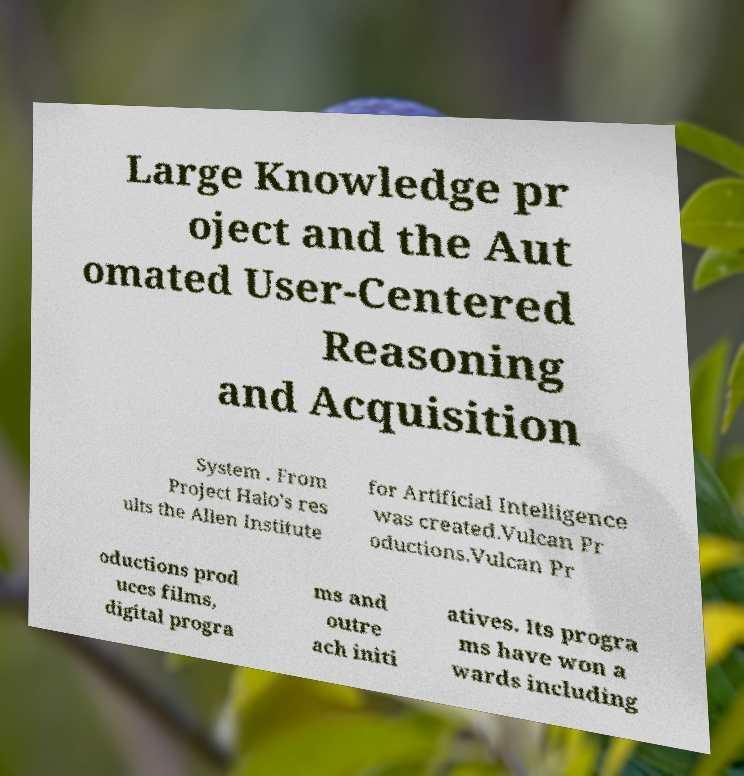Please identify and transcribe the text found in this image. Large Knowledge pr oject and the Aut omated User-Centered Reasoning and Acquisition System . From Project Halo's res ults the Allen Institute for Artificial Intelligence was created.Vulcan Pr oductions.Vulcan Pr oductions prod uces films, digital progra ms and outre ach initi atives. Its progra ms have won a wards including 